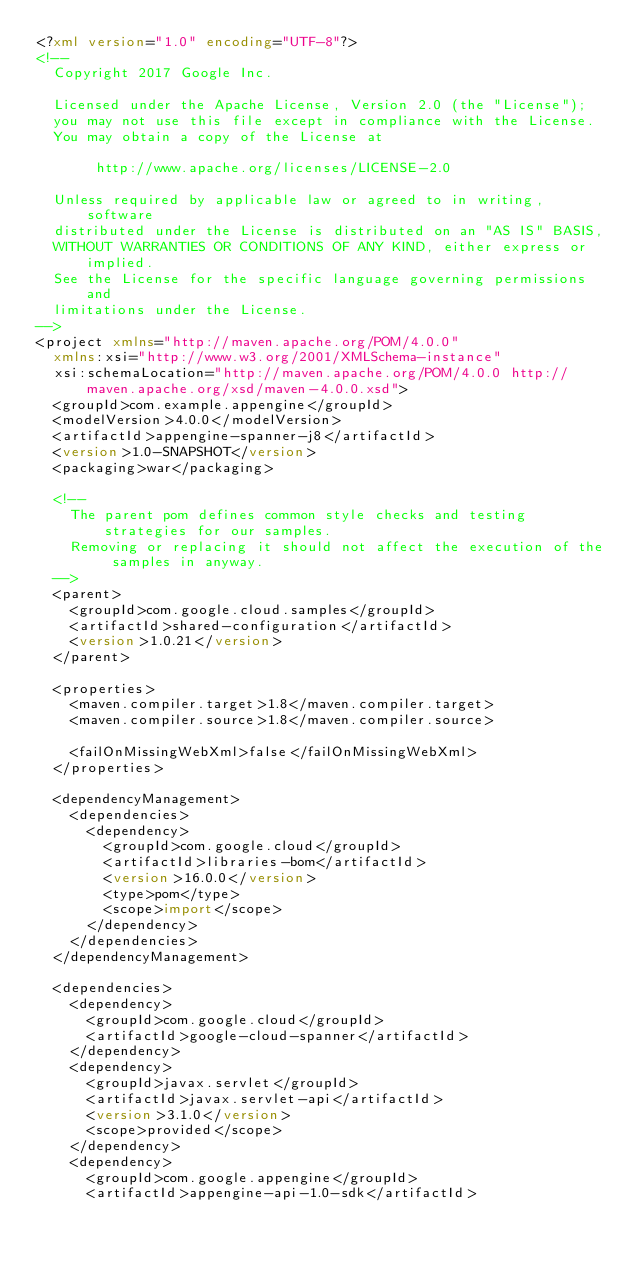Convert code to text. <code><loc_0><loc_0><loc_500><loc_500><_XML_><?xml version="1.0" encoding="UTF-8"?>
<!--
  Copyright 2017 Google Inc.

  Licensed under the Apache License, Version 2.0 (the "License");
  you may not use this file except in compliance with the License.
  You may obtain a copy of the License at

       http://www.apache.org/licenses/LICENSE-2.0

  Unless required by applicable law or agreed to in writing, software
  distributed under the License is distributed on an "AS IS" BASIS,
  WITHOUT WARRANTIES OR CONDITIONS OF ANY KIND, either express or implied.
  See the License for the specific language governing permissions and
  limitations under the License.
-->
<project xmlns="http://maven.apache.org/POM/4.0.0"
  xmlns:xsi="http://www.w3.org/2001/XMLSchema-instance"
  xsi:schemaLocation="http://maven.apache.org/POM/4.0.0 http://maven.apache.org/xsd/maven-4.0.0.xsd">
  <groupId>com.example.appengine</groupId>
  <modelVersion>4.0.0</modelVersion>
  <artifactId>appengine-spanner-j8</artifactId>
  <version>1.0-SNAPSHOT</version>
  <packaging>war</packaging>

  <!--
    The parent pom defines common style checks and testing strategies for our samples.
    Removing or replacing it should not affect the execution of the samples in anyway.
  -->
  <parent>
    <groupId>com.google.cloud.samples</groupId>
    <artifactId>shared-configuration</artifactId>
    <version>1.0.21</version>
  </parent>

  <properties>
    <maven.compiler.target>1.8</maven.compiler.target>
    <maven.compiler.source>1.8</maven.compiler.source>

    <failOnMissingWebXml>false</failOnMissingWebXml>
  </properties>
  
  <dependencyManagement>
    <dependencies>
      <dependency>
        <groupId>com.google.cloud</groupId>
        <artifactId>libraries-bom</artifactId>
        <version>16.0.0</version>
        <type>pom</type>
        <scope>import</scope>
      </dependency>
    </dependencies>
  </dependencyManagement>

  <dependencies>
    <dependency>
      <groupId>com.google.cloud</groupId>
      <artifactId>google-cloud-spanner</artifactId>
    </dependency>
    <dependency>
      <groupId>javax.servlet</groupId>
      <artifactId>javax.servlet-api</artifactId>
      <version>3.1.0</version>
      <scope>provided</scope>
    </dependency>
    <dependency>
      <groupId>com.google.appengine</groupId>
      <artifactId>appengine-api-1.0-sdk</artifactId></code> 